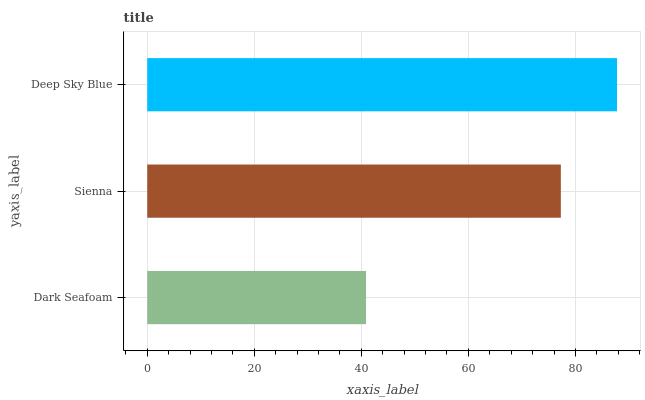Is Dark Seafoam the minimum?
Answer yes or no. Yes. Is Deep Sky Blue the maximum?
Answer yes or no. Yes. Is Sienna the minimum?
Answer yes or no. No. Is Sienna the maximum?
Answer yes or no. No. Is Sienna greater than Dark Seafoam?
Answer yes or no. Yes. Is Dark Seafoam less than Sienna?
Answer yes or no. Yes. Is Dark Seafoam greater than Sienna?
Answer yes or no. No. Is Sienna less than Dark Seafoam?
Answer yes or no. No. Is Sienna the high median?
Answer yes or no. Yes. Is Sienna the low median?
Answer yes or no. Yes. Is Deep Sky Blue the high median?
Answer yes or no. No. Is Dark Seafoam the low median?
Answer yes or no. No. 